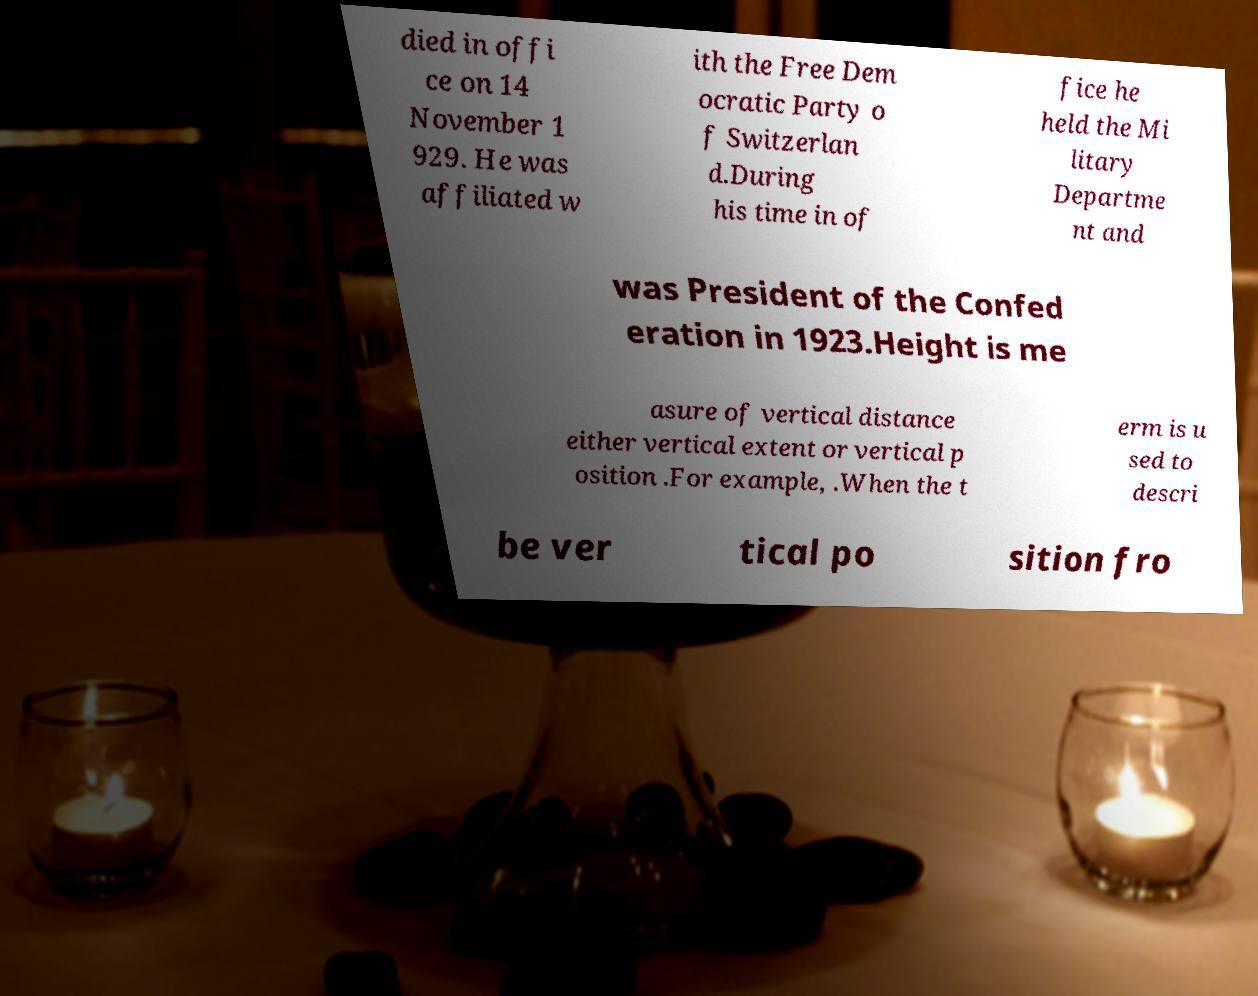Can you read and provide the text displayed in the image?This photo seems to have some interesting text. Can you extract and type it out for me? died in offi ce on 14 November 1 929. He was affiliated w ith the Free Dem ocratic Party o f Switzerlan d.During his time in of fice he held the Mi litary Departme nt and was President of the Confed eration in 1923.Height is me asure of vertical distance either vertical extent or vertical p osition .For example, .When the t erm is u sed to descri be ver tical po sition fro 